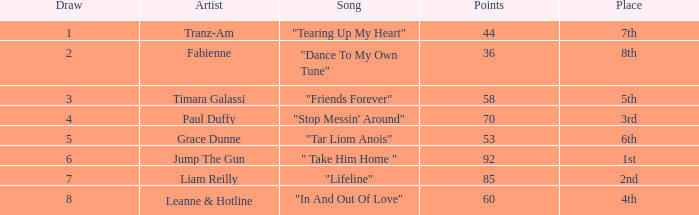What's the song of artist liam reilly? "Lifeline". 